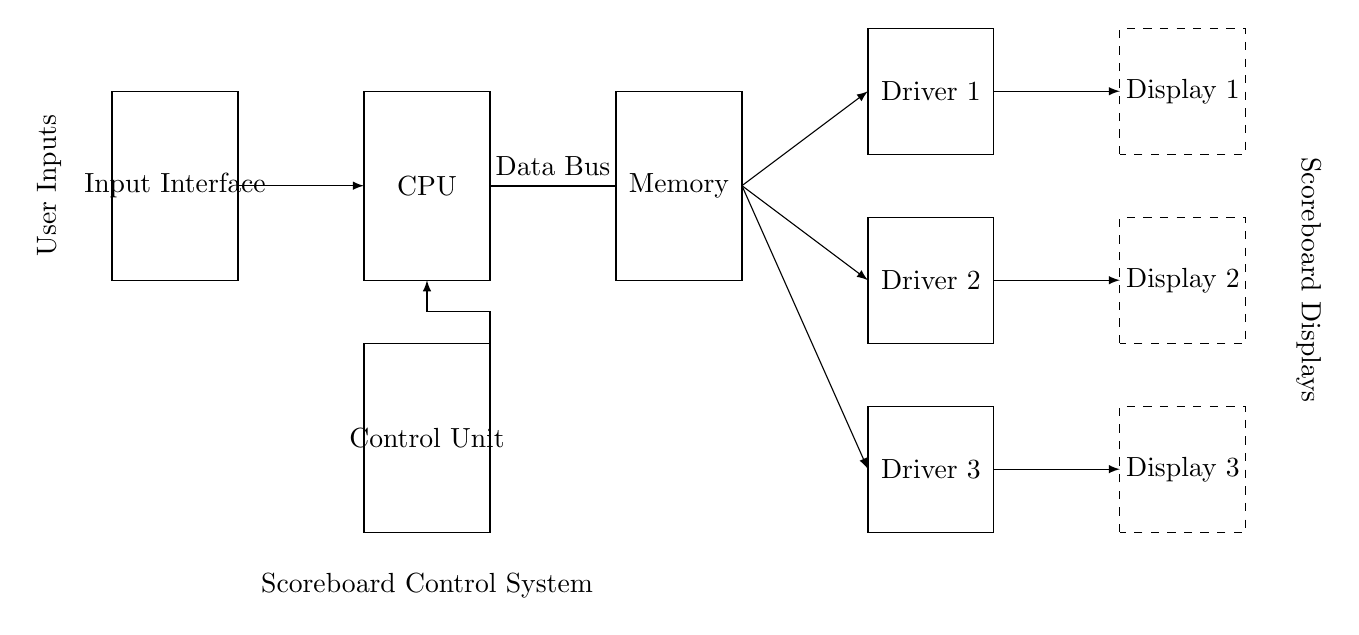What are the main components in the circuit? The main components listed are the CPU, Memory, Control Unit, Input Interface, Display Drivers, and Displays. Each component serves a unique purpose in the scoreboard control system.
Answer: CPU, Memory, Control Unit, Input Interface, Display Drivers, Displays How many display drivers are there? The circuit diagram clearly shows three distinct display drivers labeled Driver 1, Driver 2, and Driver 3. These are responsible for driving the scoreboard displays.
Answer: Three What is the function of the Control Unit? The Control Unit orchestrates the operations of the CPU, Memory, and other components, managing data flow and control signals for the scoreboard. It acts as the brain of the system.
Answer: Brain of the system Which component connects to the data bus? The data bus is connected between the CPU and Memory, indicating that it facilitates communication between these two critical components of the scoreboard control system.
Answer: CPU and Memory How is user input integrated into the system? User Inputs are connected to the Control Unit, which processes these signals and directs the flow of data to other components such as the CPU and Display Drivers.
Answer: Control Unit Which components drive the scoreboard displays? The Display Drivers, specifically Driver 1, Driver 2, and Driver 3, are responsible for controlling the output to the scoreboard displays as indicated by their direct connections.
Answer: Display Drivers Explain the relationship between Memory and Display Drivers. Memory sends data to the Display Drivers via the data bus, supplying the information needed to update the scoreboard displays based on the inputs and control signals.
Answer: Data Bus 